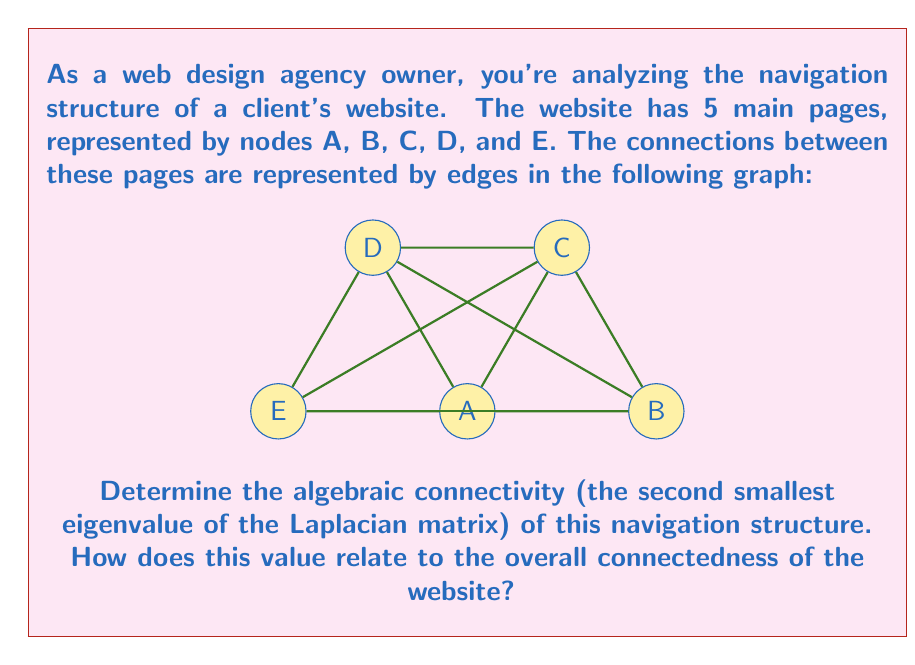Can you solve this math problem? To solve this problem, we'll follow these steps:

1) First, we need to construct the Laplacian matrix $L$ of the graph. The Laplacian matrix is defined as $L = D - A$, where $D$ is the degree matrix and $A$ is the adjacency matrix.

2) The adjacency matrix $A$ for this graph is:

   $$A = \begin{bmatrix}
   0 & 1 & 1 & 1 & 1\\
   1 & 0 & 1 & 1 & 1\\
   1 & 1 & 0 & 1 & 1\\
   1 & 1 & 1 & 0 & 1\\
   1 & 1 & 1 & 1 & 0
   \end{bmatrix}$$

3) The degree matrix $D$ is a diagonal matrix where each entry $d_{ii}$ is the degree of vertex $i$:

   $$D = \begin{bmatrix}
   4 & 0 & 0 & 0 & 0\\
   0 & 4 & 0 & 0 & 0\\
   0 & 0 & 4 & 0 & 0\\
   0 & 0 & 0 & 4 & 0\\
   0 & 0 & 0 & 0 & 4
   \end{bmatrix}$$

4) Now we can calculate the Laplacian matrix $L = D - A$:

   $$L = \begin{bmatrix}
   4 & -1 & -1 & -1 & -1\\
   -1 & 4 & -1 & -1 & -1\\
   -1 & -1 & 4 & -1 & -1\\
   -1 & -1 & -1 & 4 & -1\\
   -1 & -1 & -1 & -1 & 4
   \end{bmatrix}$$

5) To find the eigenvalues of $L$, we need to solve the characteristic equation $\det(L - \lambda I) = 0$. This gives us:

   $$(5-\lambda)(3-\lambda)^4 = 0$$

6) Solving this equation, we get the eigenvalues:
   $\lambda_1 = 0$
   $\lambda_2 = \lambda_3 = \lambda_4 = \lambda_5 = 3$

7) The algebraic connectivity is the second smallest eigenvalue, which in this case is 3.

8) The algebraic connectivity is a measure of how well-connected the graph is. A higher value indicates a more connected graph. In this case, the value of 3 is relatively high (the maximum possible for a graph with 5 vertices is 4), indicating that the website's navigation structure is very well-connected.

This high connectivity suggests that users can easily navigate between different pages of the website, which is generally desirable for user experience and SEO.
Answer: 3 (high connectivity) 